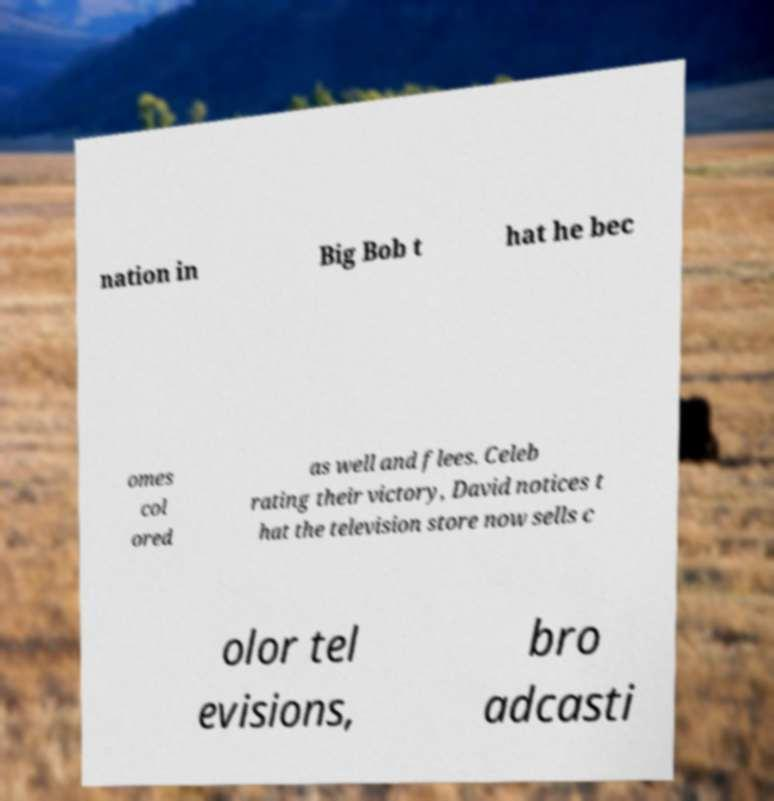Please read and relay the text visible in this image. What does it say? nation in Big Bob t hat he bec omes col ored as well and flees. Celeb rating their victory, David notices t hat the television store now sells c olor tel evisions, bro adcasti 